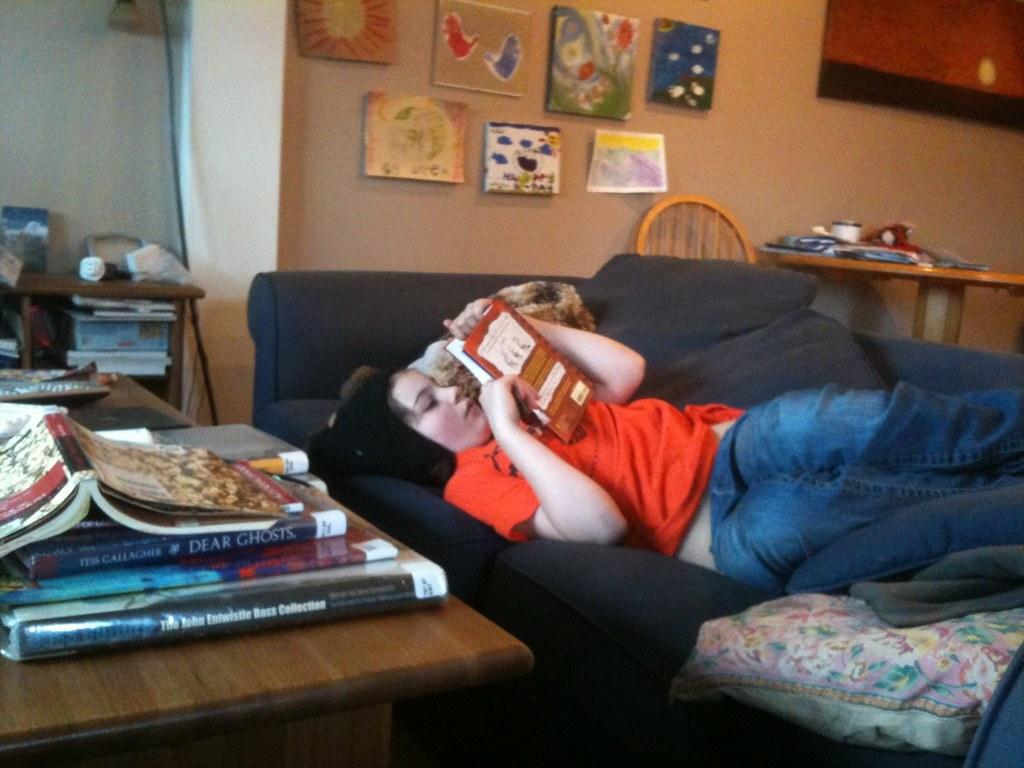What is the name of the blue book?
Your response must be concise. Dear ghosts. 